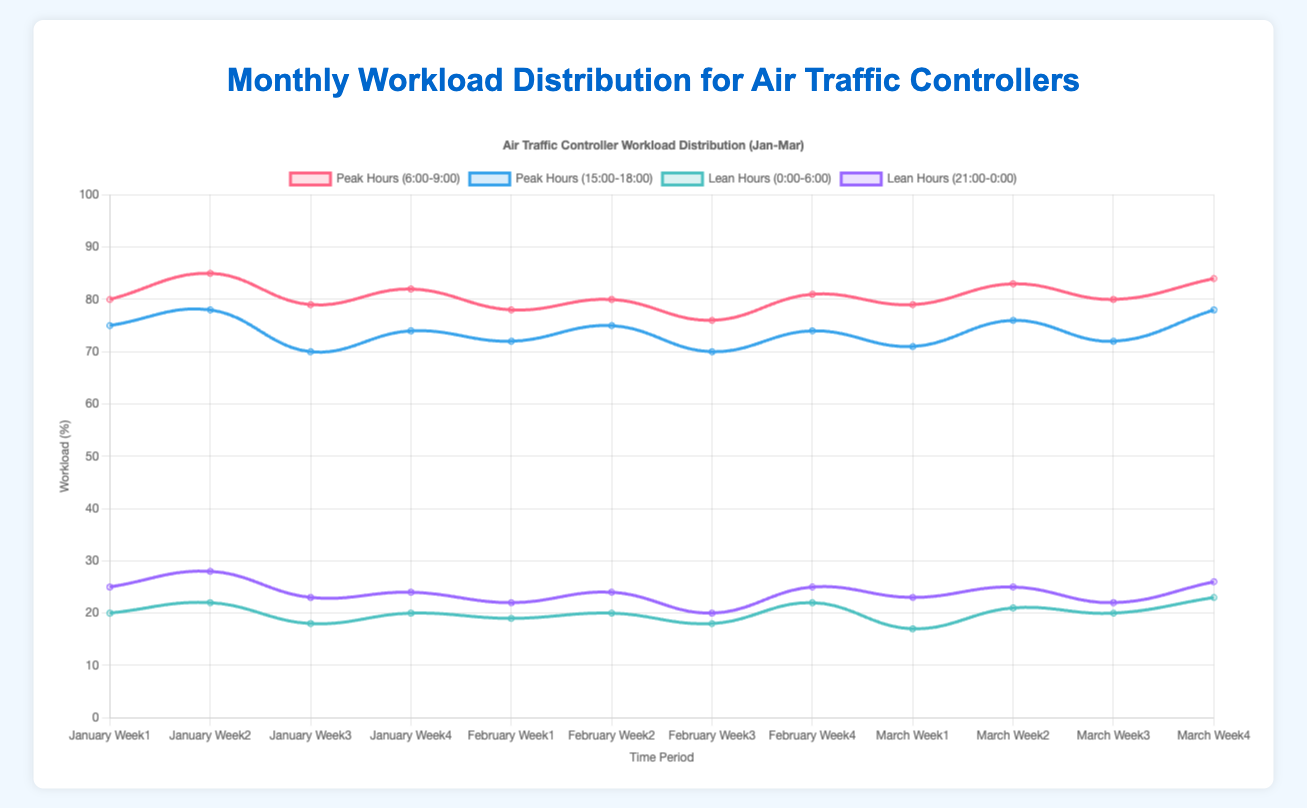How does the peak workload distribution vary between morning (6:00-9:00) and evening (15:00-18:00) hours across the period shown? To find this, observe the lines representing peak morning and peak evening hours. Compare their general trends and fluctuations. The morning peak workload tends to be slightly higher on average compared to evening peak hours, but both show a consistent up-and-down pattern with occasional peaks. Both are quite aligned but some variations can be observed.
Answer: Morning tends to be higher but with similar trends Which week in March shows the highest workload during the evening peak hours (15:00-18:00)? Identify the data points for each week in March and compare their values for 15:00-18:00 workload. The highest point for March in the evening peak hours is for Week 4.
Answer: March Week 4 What is the average workload for lean hours (0:00-6:00) in February? Sum the values for lean hours (0:00-6:00) for all weeks in February and divide by the number of weeks. The values are 19, 20, 18, and 22. (19+20+18+22)/4 = 19.75
Answer: 19.75 Compare the workload during the lean hours (21:00-0:00) for the second week of January and February. Which is higher? Look at the values for 21:00-0:00 for Week 2 in January and February. January Week 2 is 28, and February Week 2 is 24, so January is higher.
Answer: January Which time period shows the greatest fluctuation in workload during the months of January to March? Compare the variations in the lines for different periods. The morning peak hours (6:00-9:00) show the most notable fluctuations with values ranging from 76 to 85.
Answer: Morning peak hours (6:00-9:00) What is the difference between the highest peak workload in January and the highest lean workload in March? Identify the highest values for peak hours in January and lean hours in March. The highest peak workload in January is 85, and the highest lean workload in March is 26. The difference is 59 (85-26).
Answer: 59 During which week in February do the lean hours (0:00-6:00) have the lowest workload? Look at the lean hours (0:00-6:00) values for each week in February. The lowest is Week 3 with a value of 18.
Answer: Week 3 Is there a trend in the workload during peak evening hours (15:00-18:00) from January to March? Examine the line representing peak evening hours. It shows slight fluctuations but generally maintains a consistent average level without a significant increasing or decreasing trend.
Answer: No significant trend Which week has the lowest workload among all peak hours (6:00-9:00, 15:00-18:00) from January to March? Compare all data points across all weeks. March Week 1 evening (15:00-18:00) has the lowest value of 71.
Answer: March Week 1 